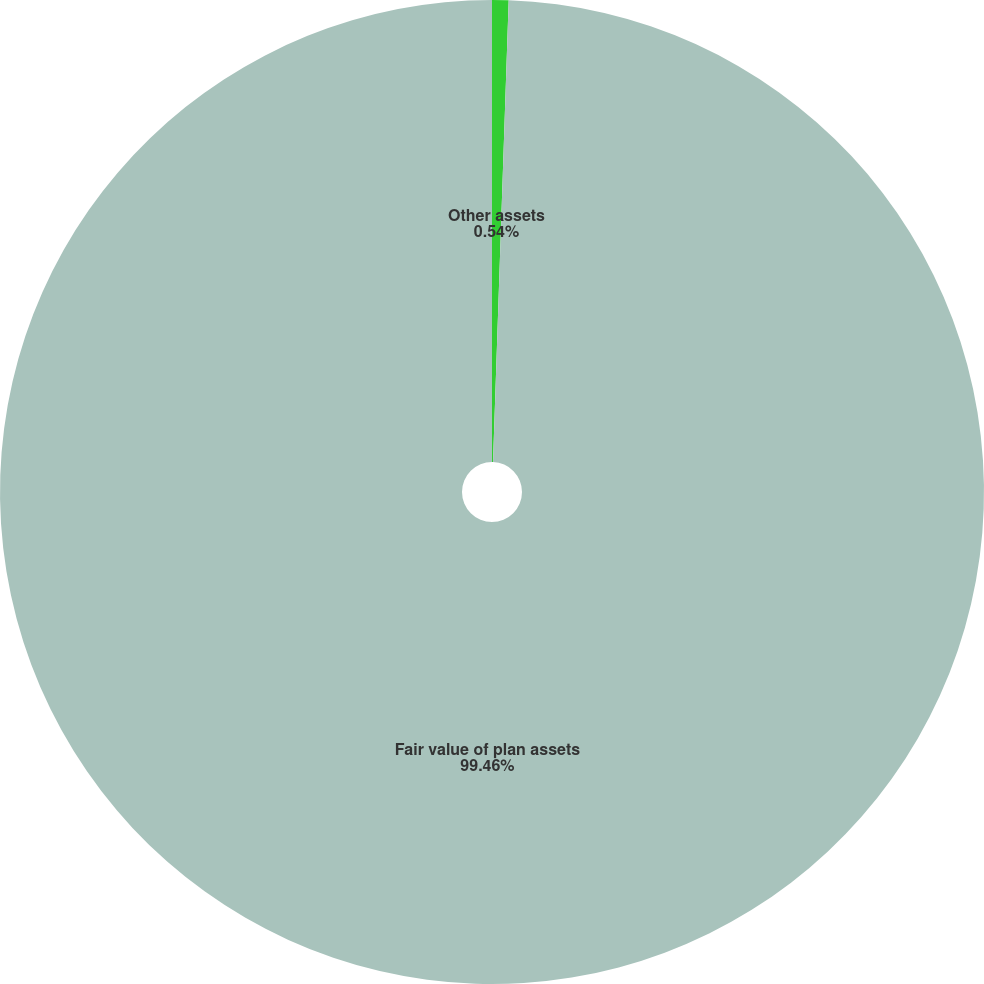Convert chart to OTSL. <chart><loc_0><loc_0><loc_500><loc_500><pie_chart><fcel>Other assets<fcel>Fair value of plan assets<nl><fcel>0.54%<fcel>99.46%<nl></chart> 